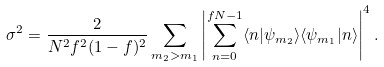<formula> <loc_0><loc_0><loc_500><loc_500>\sigma ^ { 2 } = \frac { 2 } { N ^ { 2 } f ^ { 2 } ( 1 - f ) ^ { 2 } } \sum _ { m _ { 2 } > m _ { 1 } } \left | \sum _ { n = 0 } ^ { f N - 1 } \langle n | \psi _ { m _ { 2 } } \rangle \langle \psi _ { m _ { 1 } } | n \rangle \right | ^ { 4 } .</formula> 